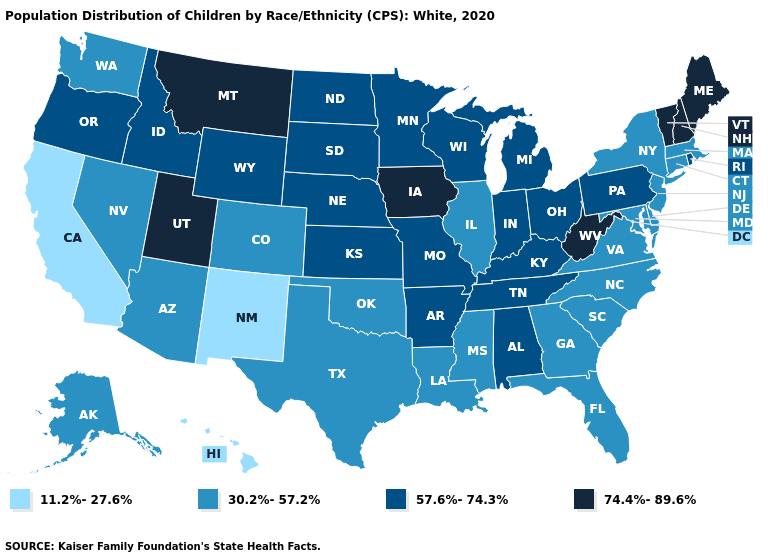Which states hav the highest value in the MidWest?
Be succinct. Iowa. Name the states that have a value in the range 11.2%-27.6%?
Keep it brief. California, Hawaii, New Mexico. Name the states that have a value in the range 11.2%-27.6%?
Short answer required. California, Hawaii, New Mexico. What is the highest value in the USA?
Concise answer only. 74.4%-89.6%. How many symbols are there in the legend?
Be succinct. 4. How many symbols are there in the legend?
Quick response, please. 4. What is the value of Nebraska?
Answer briefly. 57.6%-74.3%. Does Idaho have the highest value in the USA?
Give a very brief answer. No. Name the states that have a value in the range 11.2%-27.6%?
Short answer required. California, Hawaii, New Mexico. Which states have the highest value in the USA?
Concise answer only. Iowa, Maine, Montana, New Hampshire, Utah, Vermont, West Virginia. What is the value of Ohio?
Concise answer only. 57.6%-74.3%. Does the map have missing data?
Concise answer only. No. Name the states that have a value in the range 11.2%-27.6%?
Quick response, please. California, Hawaii, New Mexico. Name the states that have a value in the range 74.4%-89.6%?
Concise answer only. Iowa, Maine, Montana, New Hampshire, Utah, Vermont, West Virginia. Does North Dakota have the lowest value in the USA?
Be succinct. No. 